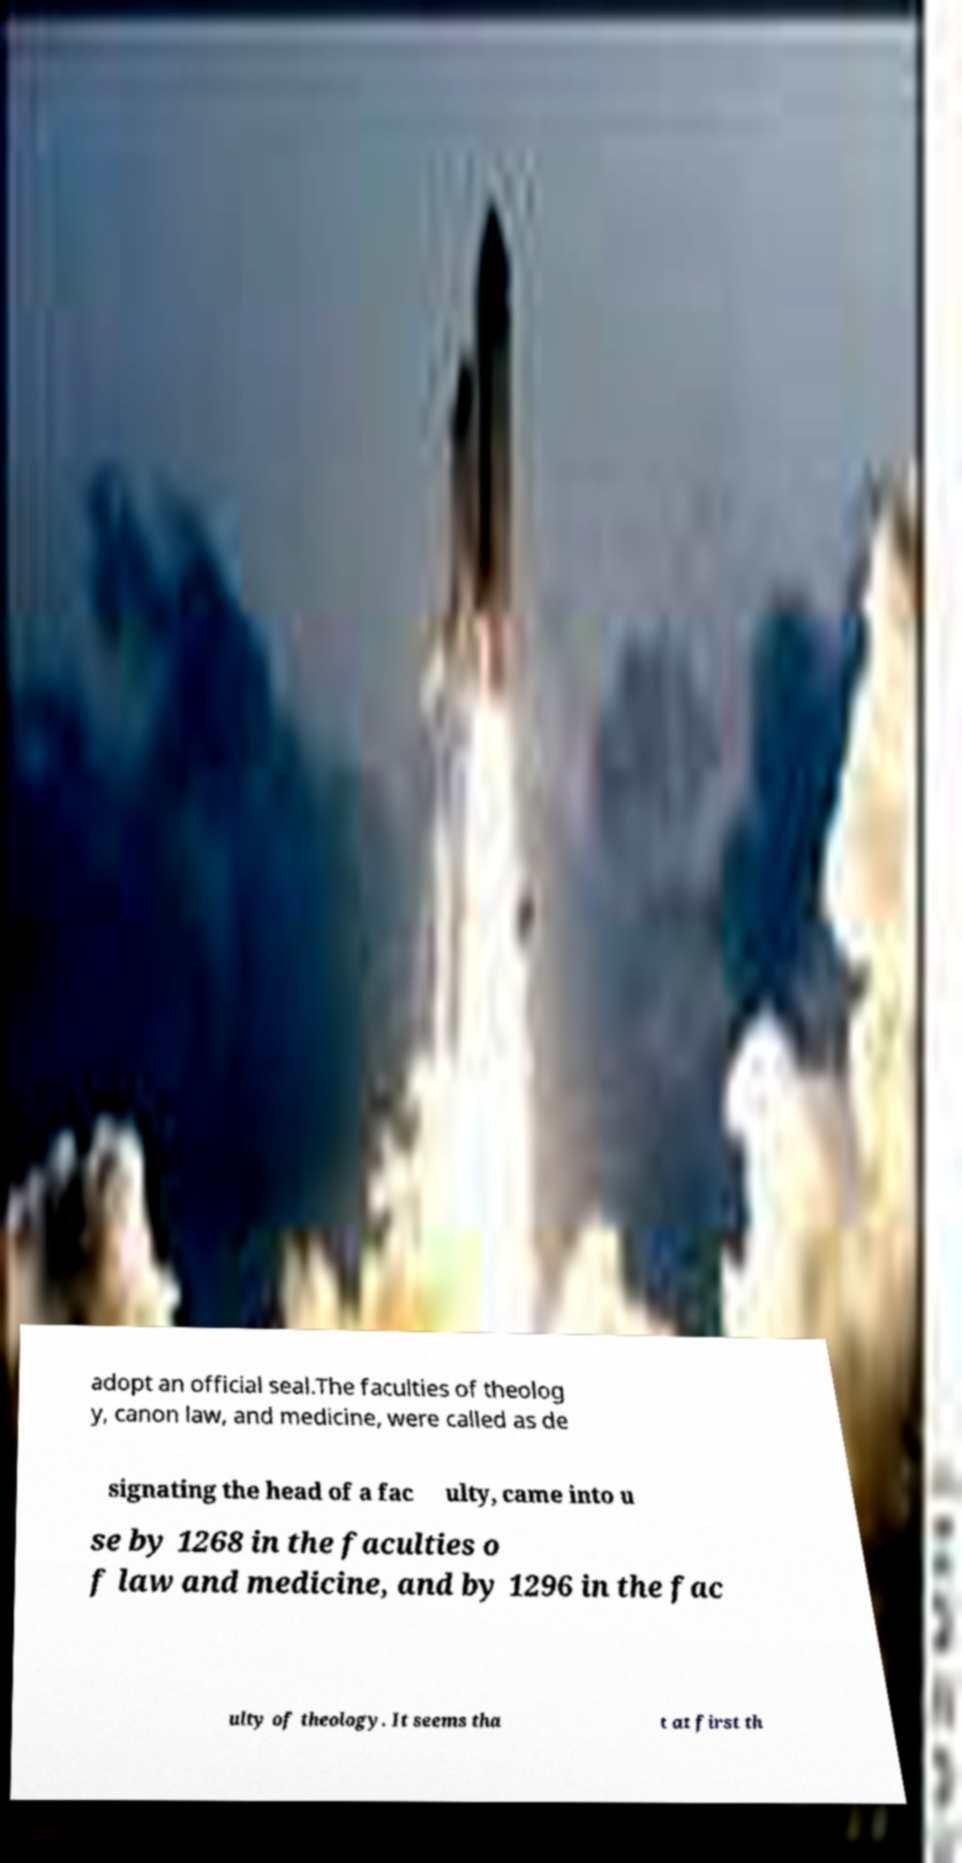Please read and relay the text visible in this image. What does it say? adopt an official seal.The faculties of theolog y, canon law, and medicine, were called as de signating the head of a fac ulty, came into u se by 1268 in the faculties o f law and medicine, and by 1296 in the fac ulty of theology. It seems tha t at first th 